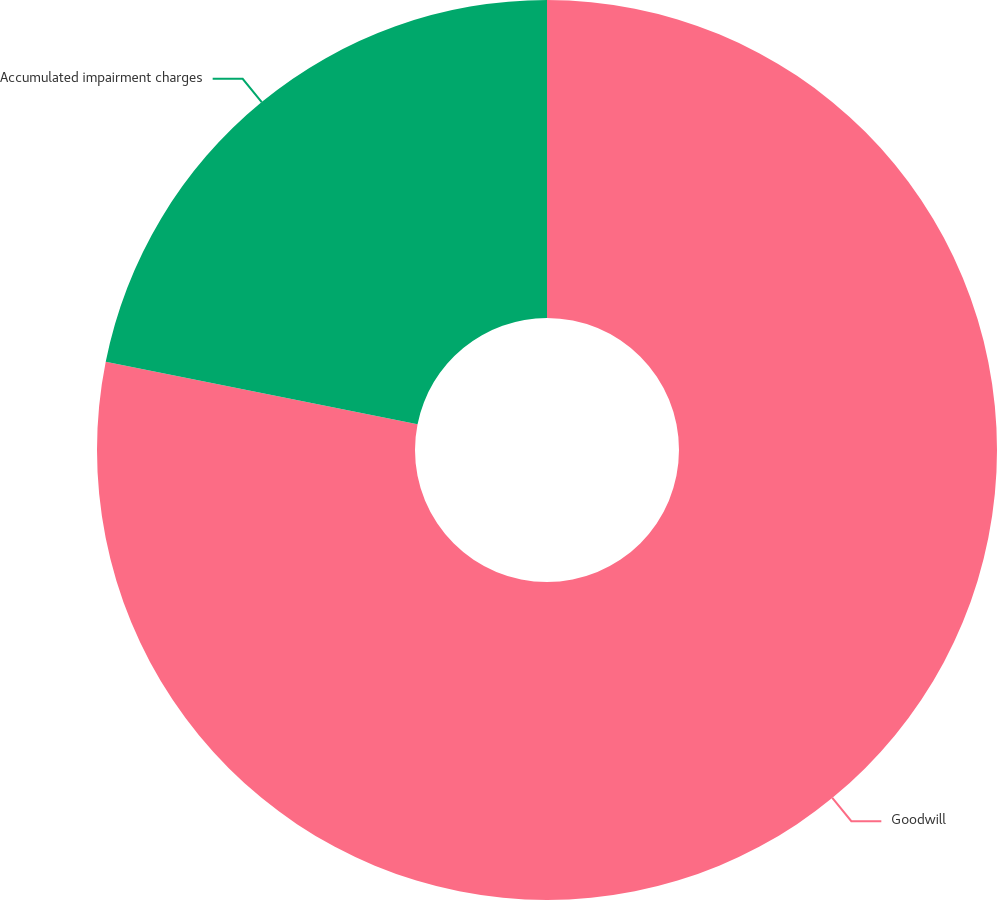<chart> <loc_0><loc_0><loc_500><loc_500><pie_chart><fcel>Goodwill<fcel>Accumulated impairment charges<nl><fcel>78.14%<fcel>21.86%<nl></chart> 